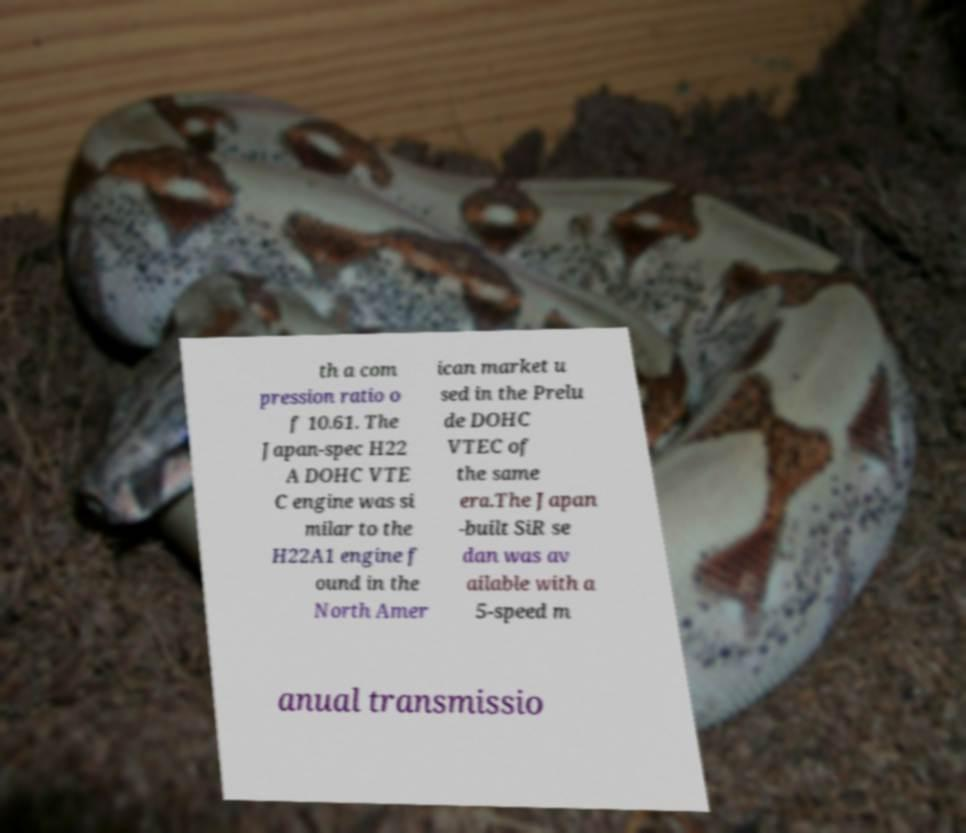There's text embedded in this image that I need extracted. Can you transcribe it verbatim? th a com pression ratio o f 10.61. The Japan-spec H22 A DOHC VTE C engine was si milar to the H22A1 engine f ound in the North Amer ican market u sed in the Prelu de DOHC VTEC of the same era.The Japan -built SiR se dan was av ailable with a 5-speed m anual transmissio 